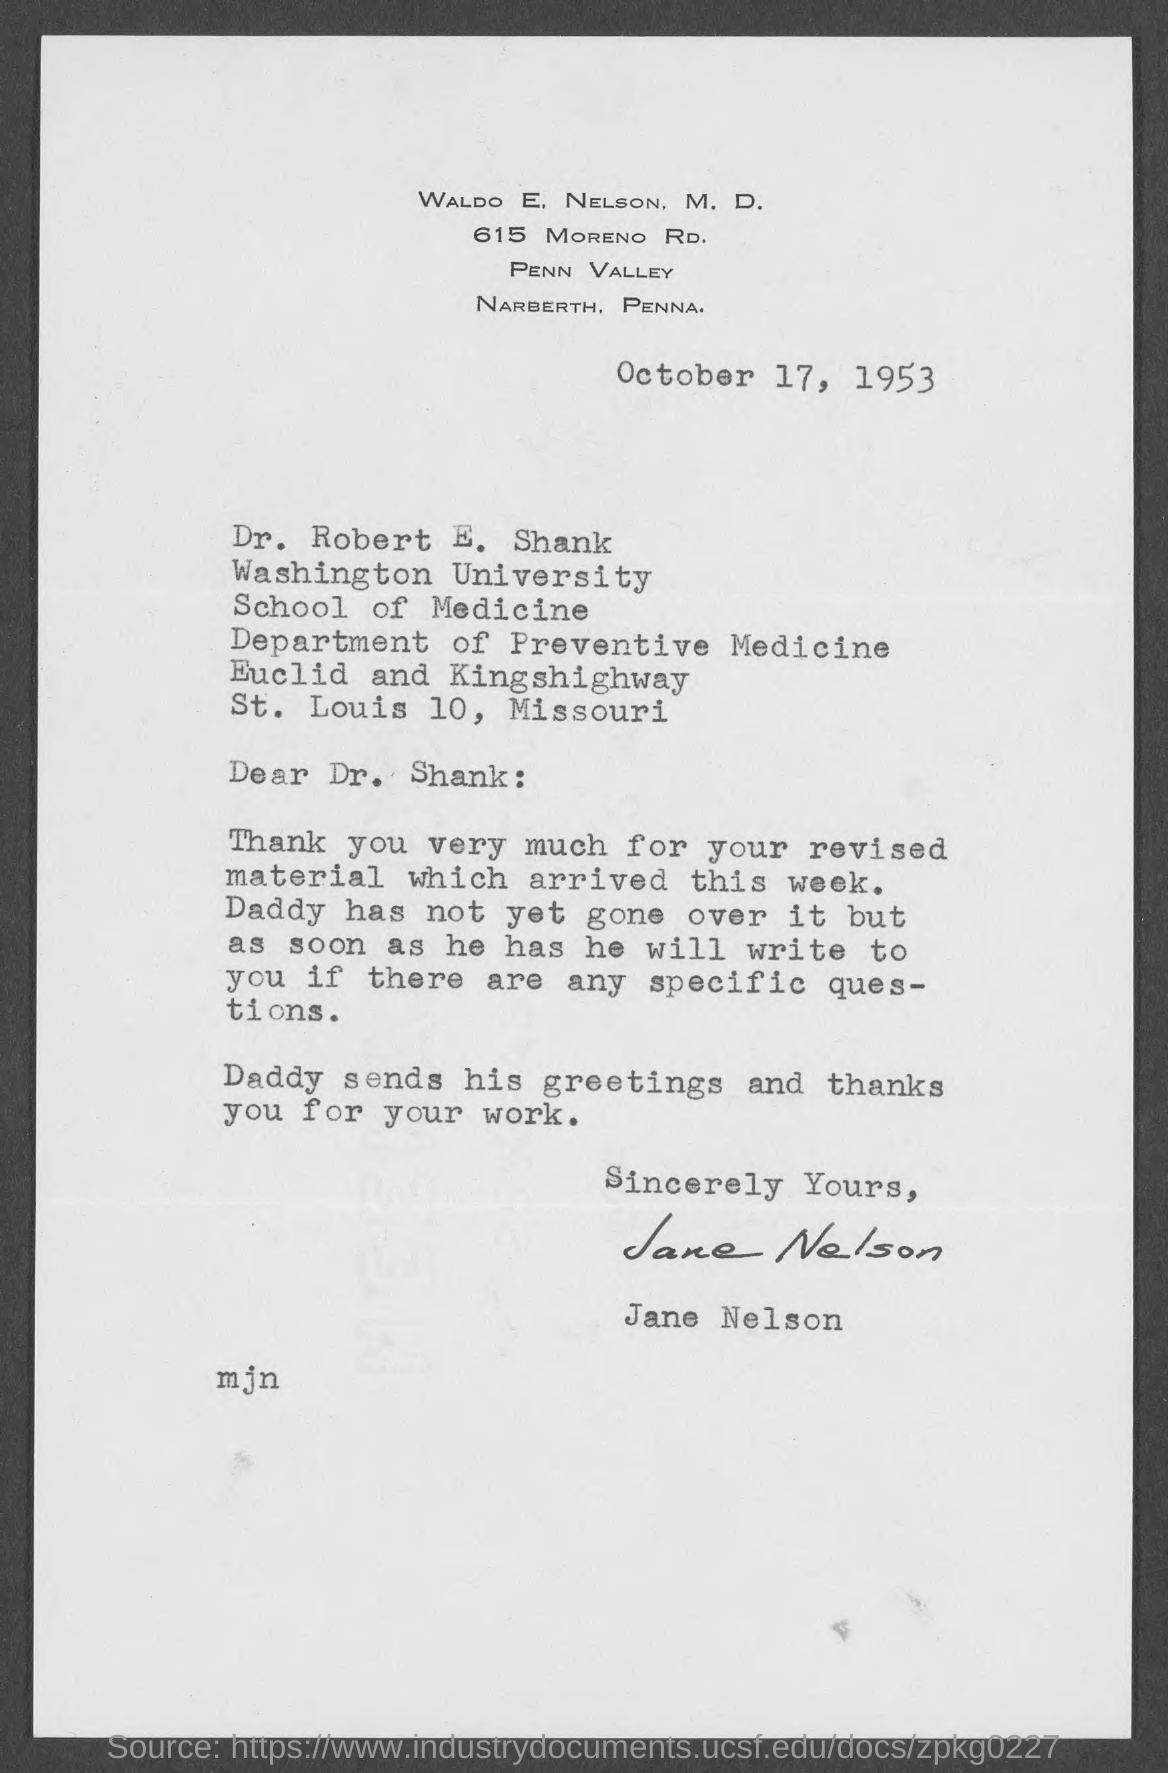What is the date on the letter?
Ensure brevity in your answer.  October 17, 1953. To whom is this letter addressed to?
Offer a terse response. Dr. Robert E. Shank. Who is this letter from?
Your answer should be compact. Jane Nelson. When did the revised material arrive?
Provide a succinct answer. This week. 